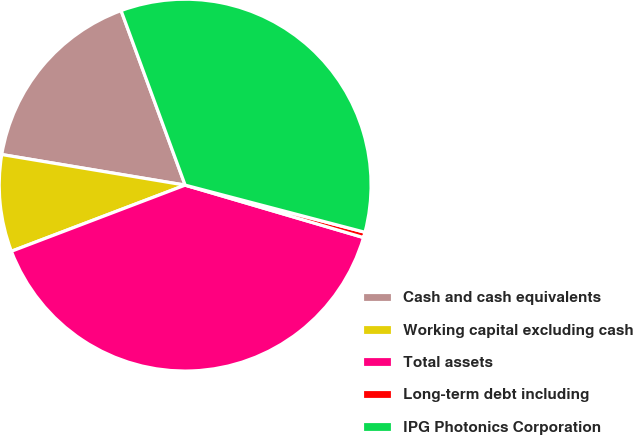Convert chart. <chart><loc_0><loc_0><loc_500><loc_500><pie_chart><fcel>Cash and cash equivalents<fcel>Working capital excluding cash<fcel>Total assets<fcel>Long-term debt including<fcel>IPG Photonics Corporation<nl><fcel>16.77%<fcel>8.42%<fcel>39.66%<fcel>0.47%<fcel>34.68%<nl></chart> 